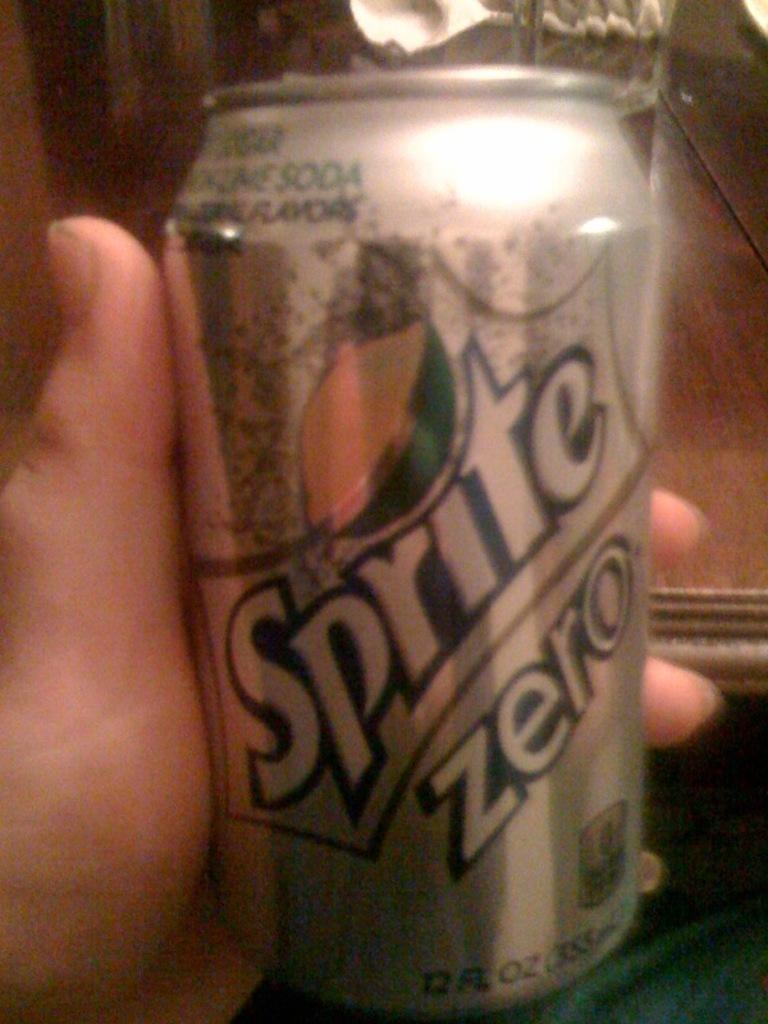What is present in the image? There is a person in the image. What is the person holding in the image? The person is holding a soft drink tin. Can you see any ghosts in the image? There are no ghosts present in the image. What type of pan is being used by the person in the image? There is no pan visible in the image; the person is holding a soft drink tin. 